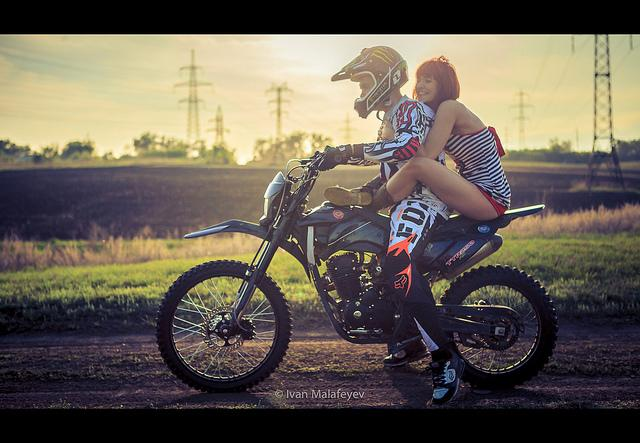Who is wearing the most safety gear? Please explain your reasoning. man. The man is wearing a helmet, gloves, elbow pads and knee pads. 